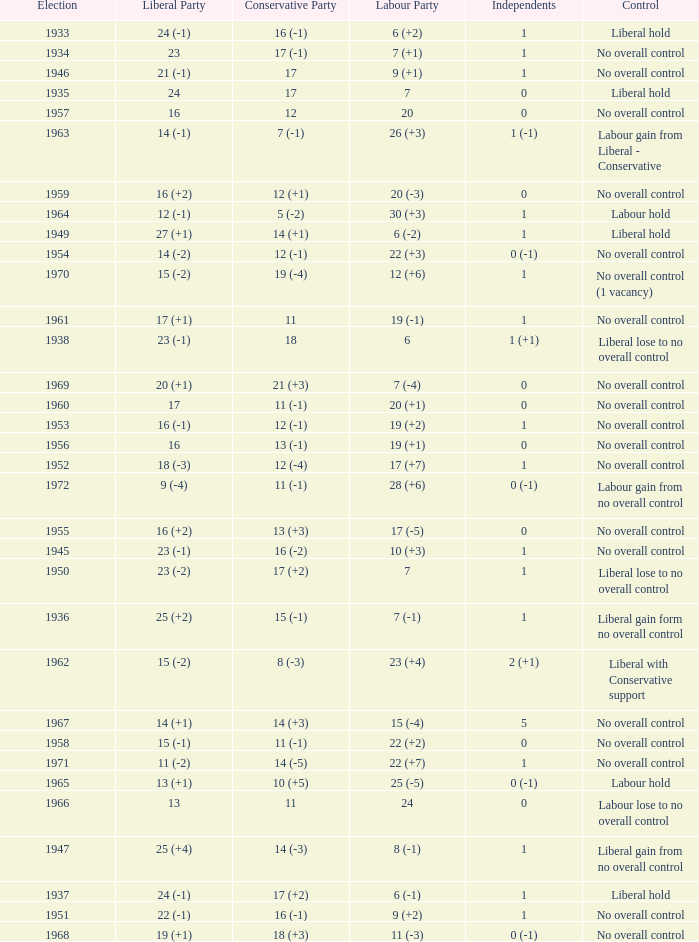What was the Liberal Party result from the election having a Conservative Party result of 16 (-1) and Labour of 6 (+2)? 24 (-1). 